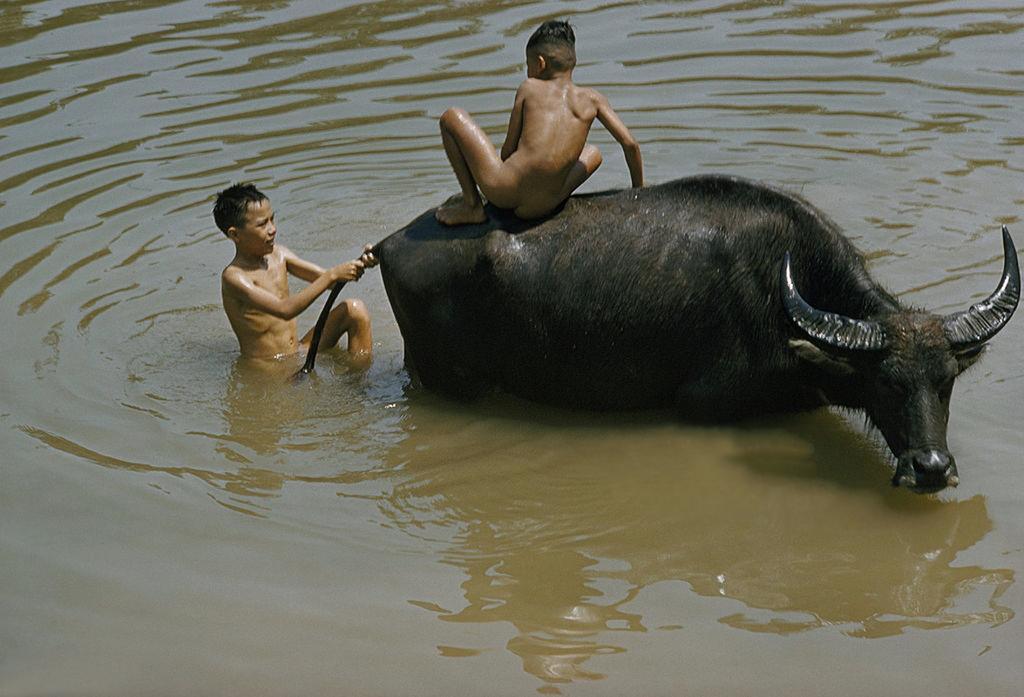Please provide a concise description of this image. In this picture there is a boy sitting on the buffalo and there is boy standing and holding the tail of the buffalo. At the bottom there is water. 